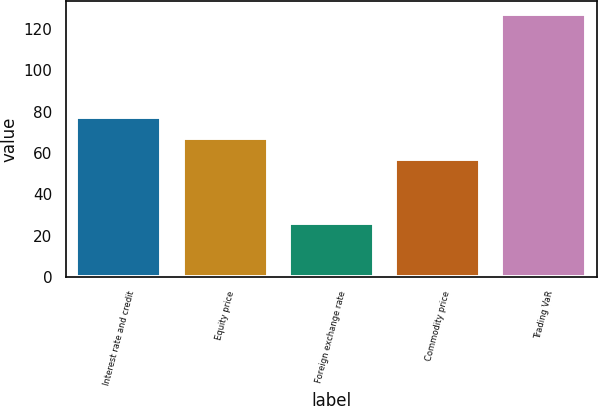Convert chart. <chart><loc_0><loc_0><loc_500><loc_500><bar_chart><fcel>Interest rate and credit<fcel>Equity price<fcel>Foreign exchange rate<fcel>Commodity price<fcel>Trading VaR<nl><fcel>77.2<fcel>67.1<fcel>26<fcel>57<fcel>127<nl></chart> 